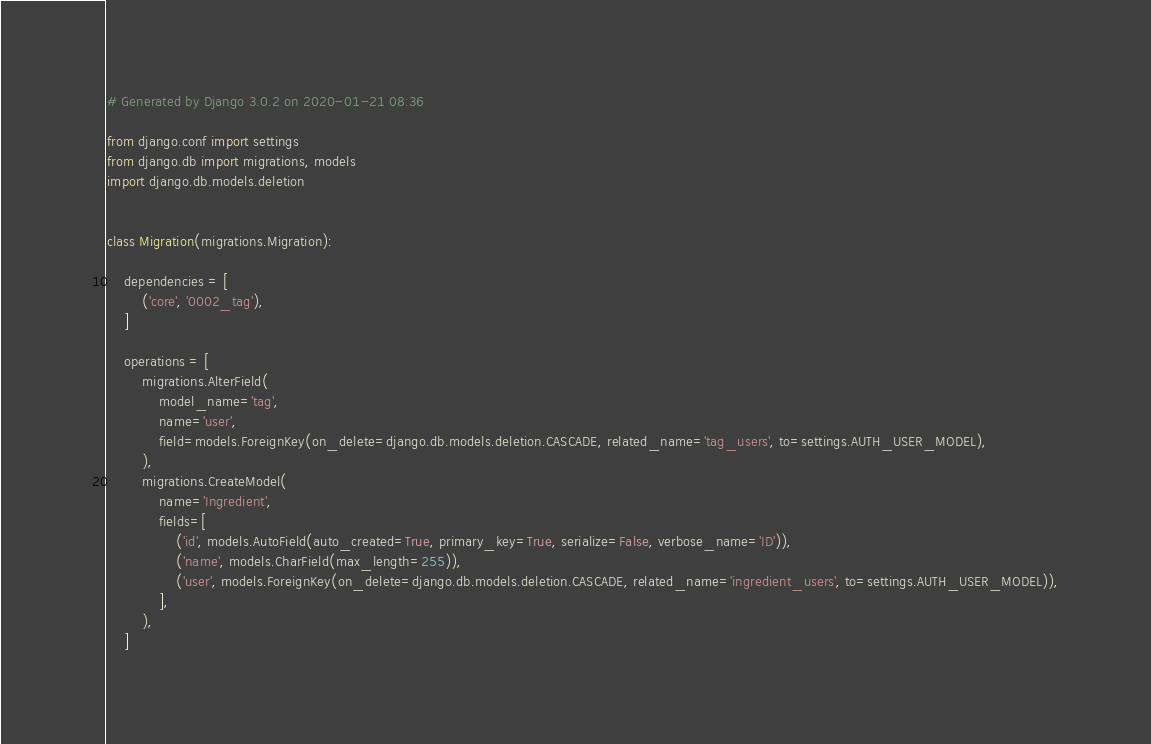Convert code to text. <code><loc_0><loc_0><loc_500><loc_500><_Python_># Generated by Django 3.0.2 on 2020-01-21 08:36

from django.conf import settings
from django.db import migrations, models
import django.db.models.deletion


class Migration(migrations.Migration):

    dependencies = [
        ('core', '0002_tag'),
    ]

    operations = [
        migrations.AlterField(
            model_name='tag',
            name='user',
            field=models.ForeignKey(on_delete=django.db.models.deletion.CASCADE, related_name='tag_users', to=settings.AUTH_USER_MODEL),
        ),
        migrations.CreateModel(
            name='Ingredient',
            fields=[
                ('id', models.AutoField(auto_created=True, primary_key=True, serialize=False, verbose_name='ID')),
                ('name', models.CharField(max_length=255)),
                ('user', models.ForeignKey(on_delete=django.db.models.deletion.CASCADE, related_name='ingredient_users', to=settings.AUTH_USER_MODEL)),
            ],
        ),
    ]
</code> 